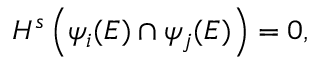Convert formula to latex. <formula><loc_0><loc_0><loc_500><loc_500>H ^ { s } \left ( \psi _ { i } ( E ) \cap \psi _ { j } ( E ) \right ) = 0 ,</formula> 